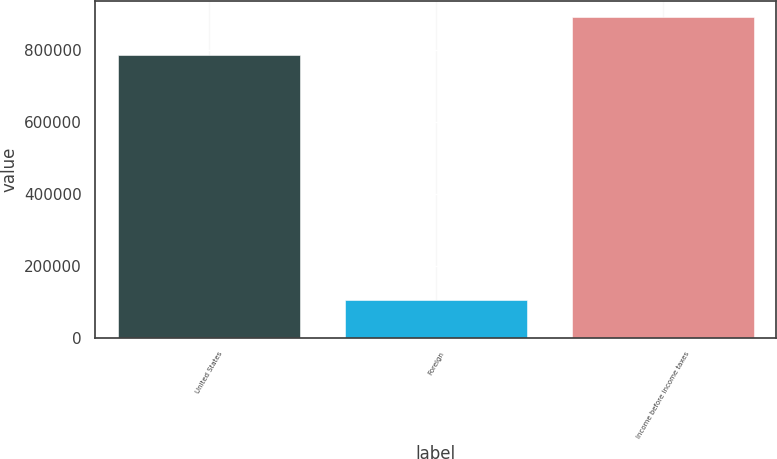<chart> <loc_0><loc_0><loc_500><loc_500><bar_chart><fcel>United States<fcel>Foreign<fcel>Income before income taxes<nl><fcel>784841<fcel>105965<fcel>890806<nl></chart> 